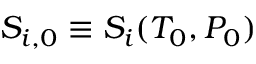Convert formula to latex. <formula><loc_0><loc_0><loc_500><loc_500>S _ { i , 0 } \equiv S _ { i } ( T _ { 0 } , P _ { 0 } )</formula> 